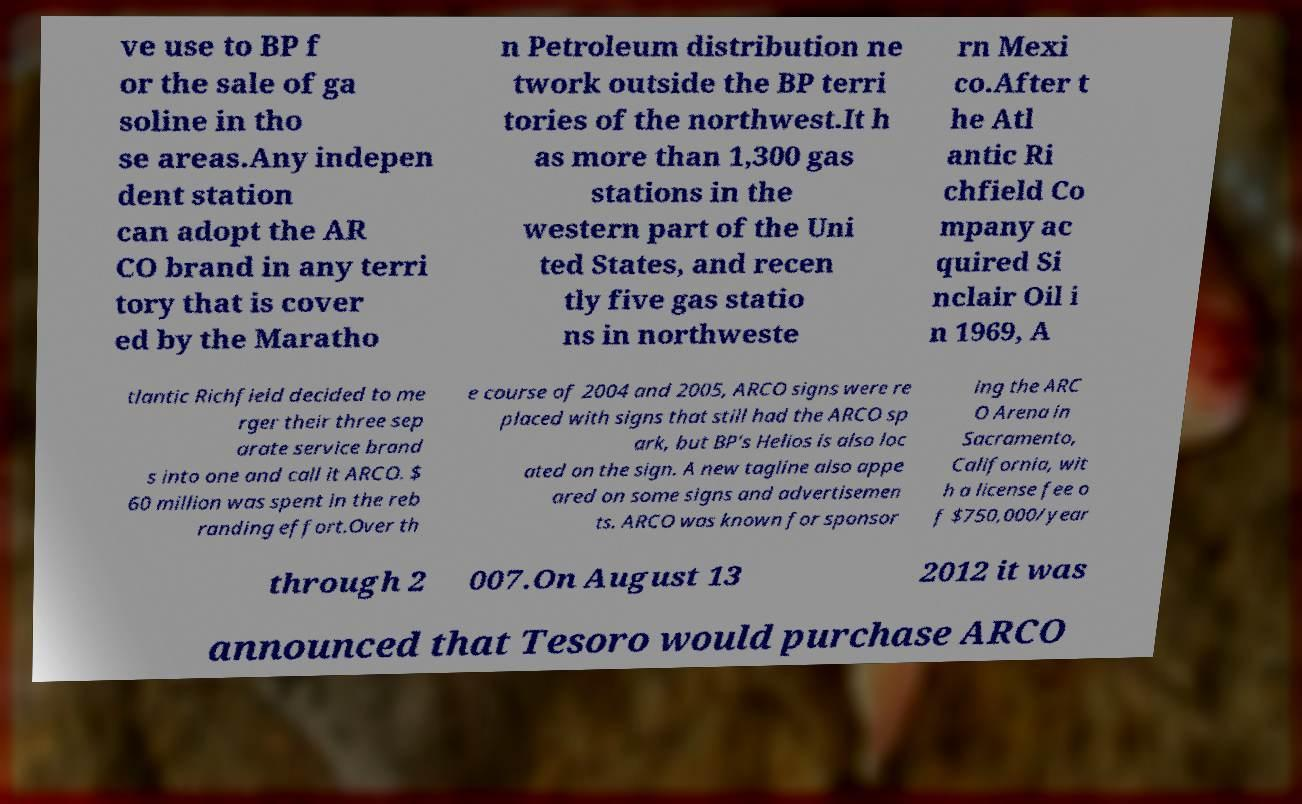Could you assist in decoding the text presented in this image and type it out clearly? ve use to BP f or the sale of ga soline in tho se areas.Any indepen dent station can adopt the AR CO brand in any terri tory that is cover ed by the Maratho n Petroleum distribution ne twork outside the BP terri tories of the northwest.It h as more than 1,300 gas stations in the western part of the Uni ted States, and recen tly five gas statio ns in northweste rn Mexi co.After t he Atl antic Ri chfield Co mpany ac quired Si nclair Oil i n 1969, A tlantic Richfield decided to me rger their three sep arate service brand s into one and call it ARCO. $ 60 million was spent in the reb randing effort.Over th e course of 2004 and 2005, ARCO signs were re placed with signs that still had the ARCO sp ark, but BP's Helios is also loc ated on the sign. A new tagline also appe ared on some signs and advertisemen ts. ARCO was known for sponsor ing the ARC O Arena in Sacramento, California, wit h a license fee o f $750,000/year through 2 007.On August 13 2012 it was announced that Tesoro would purchase ARCO 